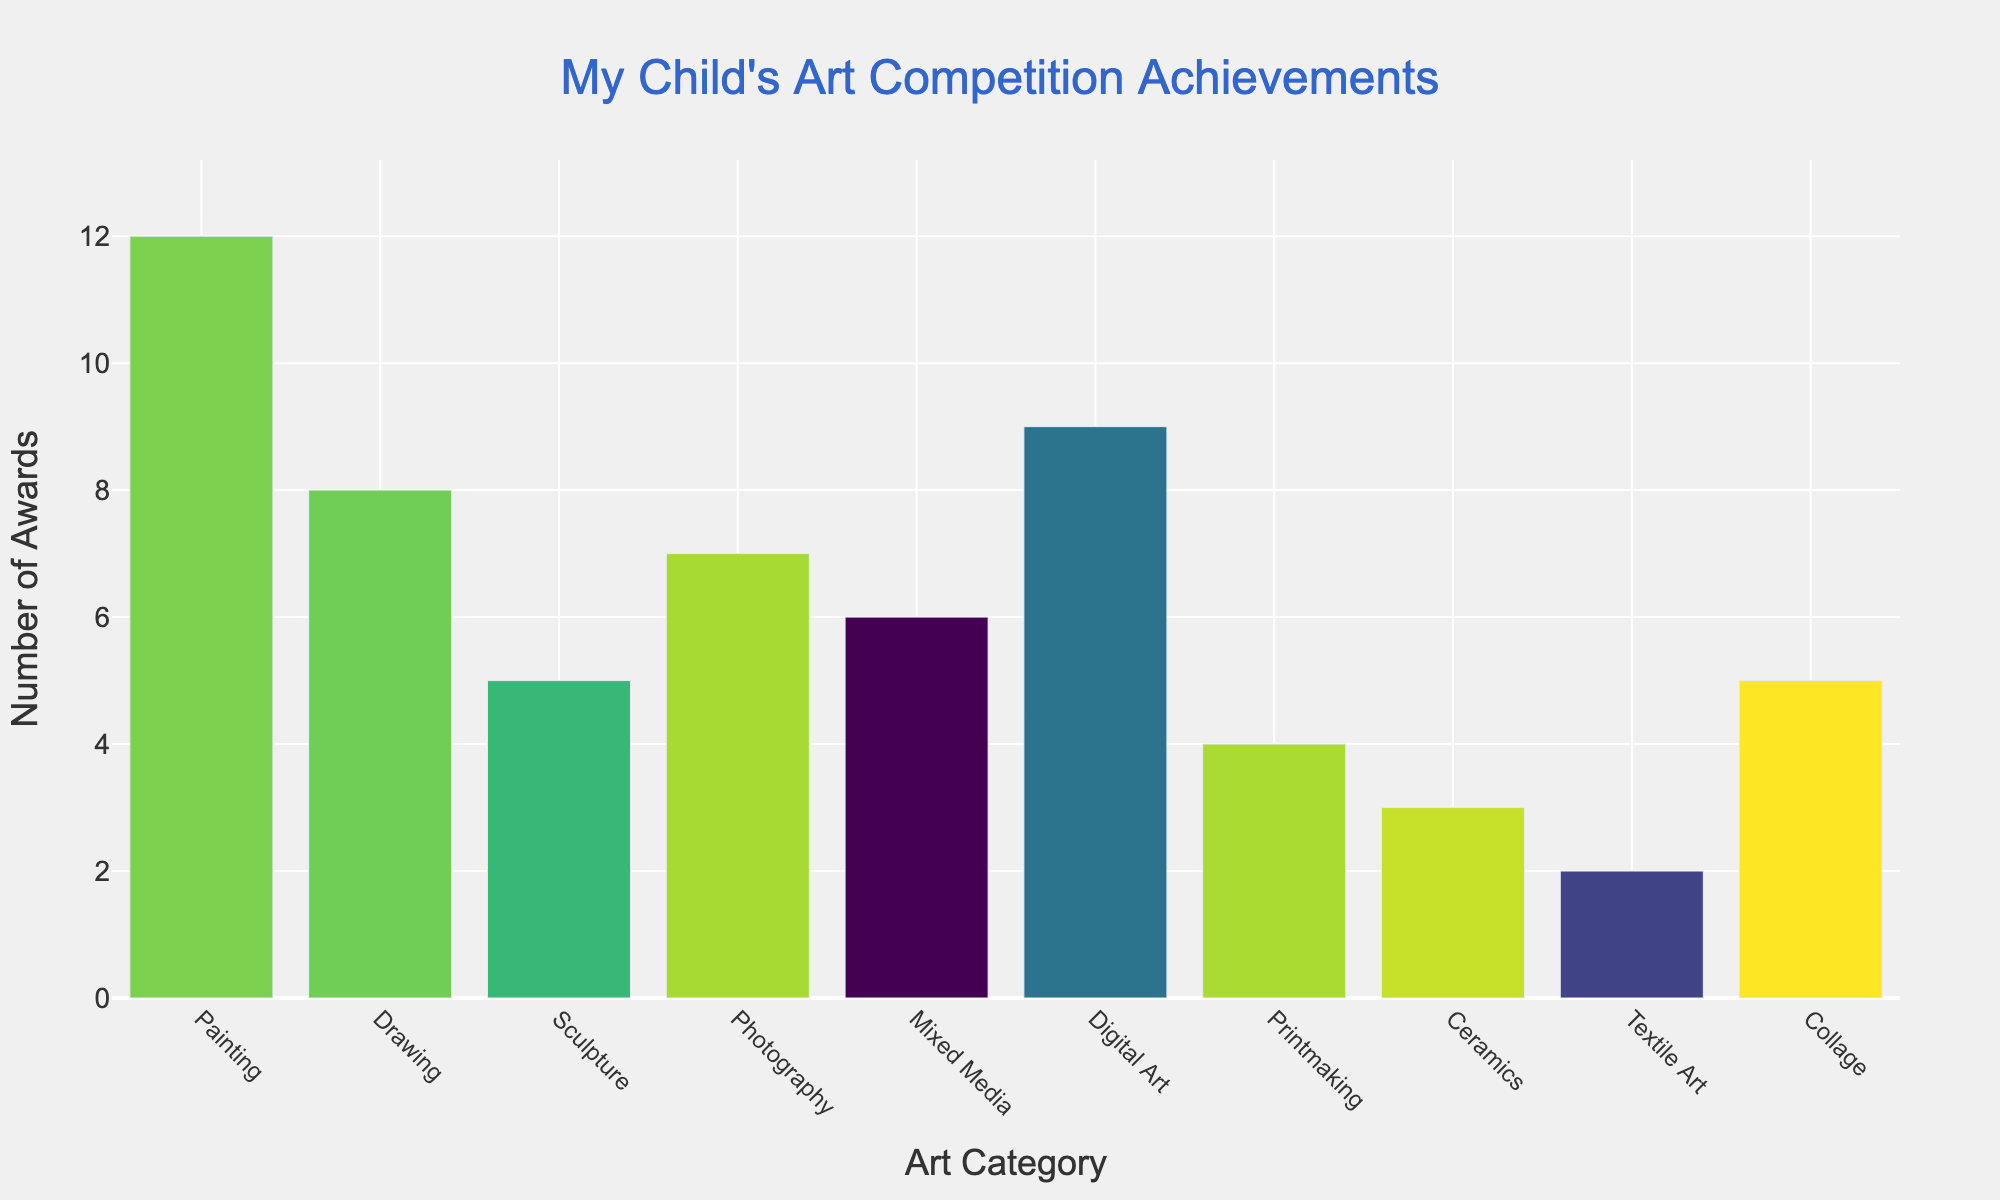Which category has the highest number of awards? The Painting category has the highest bar in the figure, with a height corresponding to 12 awards.
Answer: Painting How many more awards does Digital Art have compared to Sculpture? Digital Art has 9 awards while Sculpture has 5 awards. The difference is calculated as \(9 - 5 = 4\).
Answer: 4 What is the total number of awards won in Mixed Media, Photography, and Collage combined? Mixed Media has 6 awards, Photography has 7 awards, and Collage has 5 awards. The total is \(6 + 7 + 5 = 18\).
Answer: 18 Is the number of awards in Drawing greater than in Photography? Drawing has 8 awards and Photography has 7 awards. Since \(8 > 7\), Drawing has more awards.
Answer: Yes Which categories have fewer than 5 awards each? Ceramics and Textile Art are the categories with 3 and 2 awards respectively, both are fewer than 5.
Answer: Ceramics, Textile Art What is the range of the number of awards in the different categories? The range is calculated as the difference between the maximum and minimum values. The maximum is 12 (Painting) and the minimum is 2 (Textile Art). So, the range is \(12 - 2 = 10\).
Answer: 10 Which categories have an equal number of awards? Sculpture and Collage both have 5 awards each.
Answer: Sculpture, Collage How many total awards have been won across all categories? Sum all the "Number of Awards" values: \(12 + 8 + 5 + 7 + 6 + 9 + 4 + 3 + 2 + 5 = 61\).
Answer: 61 What is the average number of awards per category? The total number of awards is 61 and there are 10 categories, so the average is computed as \(61 / 10 = 6.1\).
Answer: 6.1 What is the difference between the number of awards in Printmaking and Ceramics? Printmaking has 4 awards and Ceramics has 3 awards. The difference is \(4 - 3 = 1\).
Answer: 1 